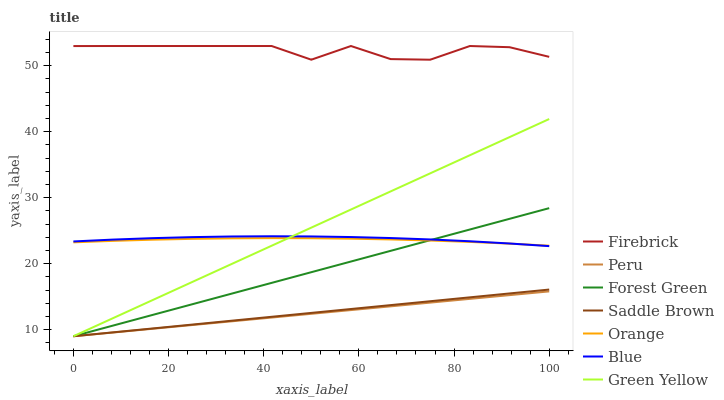Does Peru have the minimum area under the curve?
Answer yes or no. Yes. Does Firebrick have the maximum area under the curve?
Answer yes or no. Yes. Does Forest Green have the minimum area under the curve?
Answer yes or no. No. Does Forest Green have the maximum area under the curve?
Answer yes or no. No. Is Saddle Brown the smoothest?
Answer yes or no. Yes. Is Firebrick the roughest?
Answer yes or no. Yes. Is Forest Green the smoothest?
Answer yes or no. No. Is Forest Green the roughest?
Answer yes or no. No. Does Forest Green have the lowest value?
Answer yes or no. Yes. Does Firebrick have the lowest value?
Answer yes or no. No. Does Firebrick have the highest value?
Answer yes or no. Yes. Does Forest Green have the highest value?
Answer yes or no. No. Is Saddle Brown less than Blue?
Answer yes or no. Yes. Is Firebrick greater than Blue?
Answer yes or no. Yes. Does Saddle Brown intersect Green Yellow?
Answer yes or no. Yes. Is Saddle Brown less than Green Yellow?
Answer yes or no. No. Is Saddle Brown greater than Green Yellow?
Answer yes or no. No. Does Saddle Brown intersect Blue?
Answer yes or no. No. 